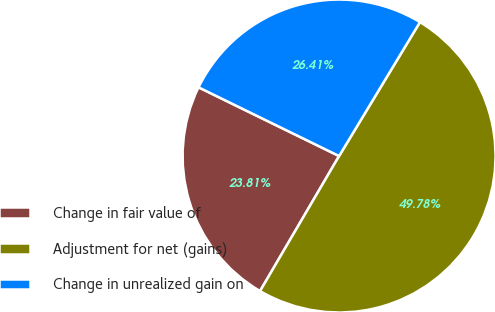Convert chart. <chart><loc_0><loc_0><loc_500><loc_500><pie_chart><fcel>Change in fair value of<fcel>Adjustment for net (gains)<fcel>Change in unrealized gain on<nl><fcel>23.81%<fcel>49.78%<fcel>26.41%<nl></chart> 